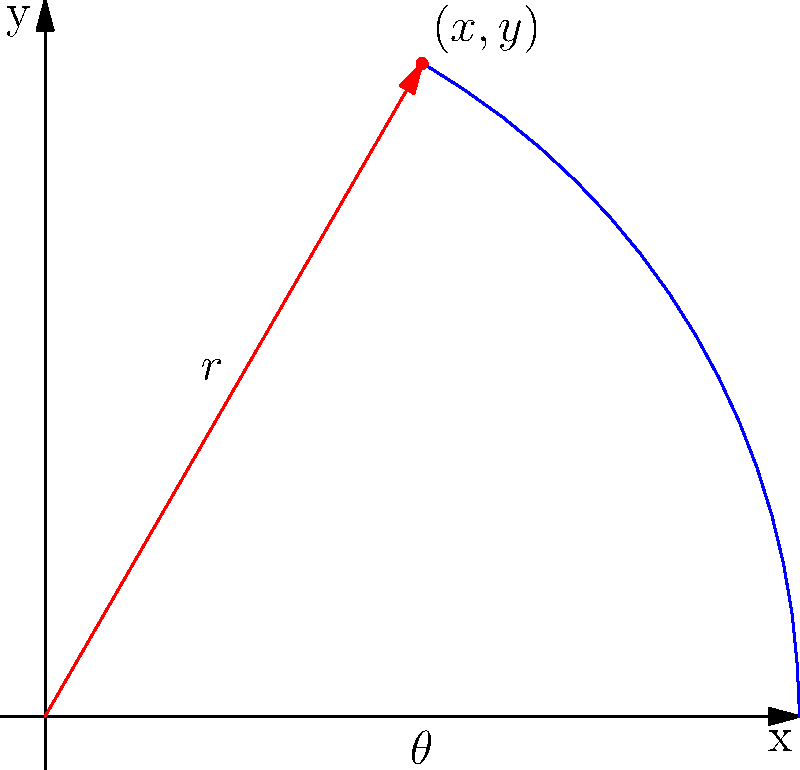You've discovered a unique vantage point for an urban photography shoot. The location is best described using polar coordinates, with $r=5$ units and $\theta=\frac{\pi}{3}$ radians from the city center. To communicate this spot to your assistant who uses a Cartesian coordinate system, what are the $(x,y)$ coordinates of this location? To convert from polar coordinates $(r,\theta)$ to Cartesian coordinates $(x,y)$, we use these formulas:

1) $x = r \cos(\theta)$
2) $y = r \sin(\theta)$

Given:
$r = 5$
$\theta = \frac{\pi}{3}$

Step 1: Calculate x
$x = 5 \cos(\frac{\pi}{3})$
$x = 5 \cdot \frac{1}{2} = \frac{5}{2} = 2.5$

Step 2: Calculate y
$y = 5 \sin(\frac{\pi}{3})$
$y = 5 \cdot \frac{\sqrt{3}}{2} = \frac{5\sqrt{3}}{2} \approx 4.33$

Therefore, the Cartesian coordinates are approximately $(2.5, 4.33)$.
Answer: $(2.5, 4.33)$ 